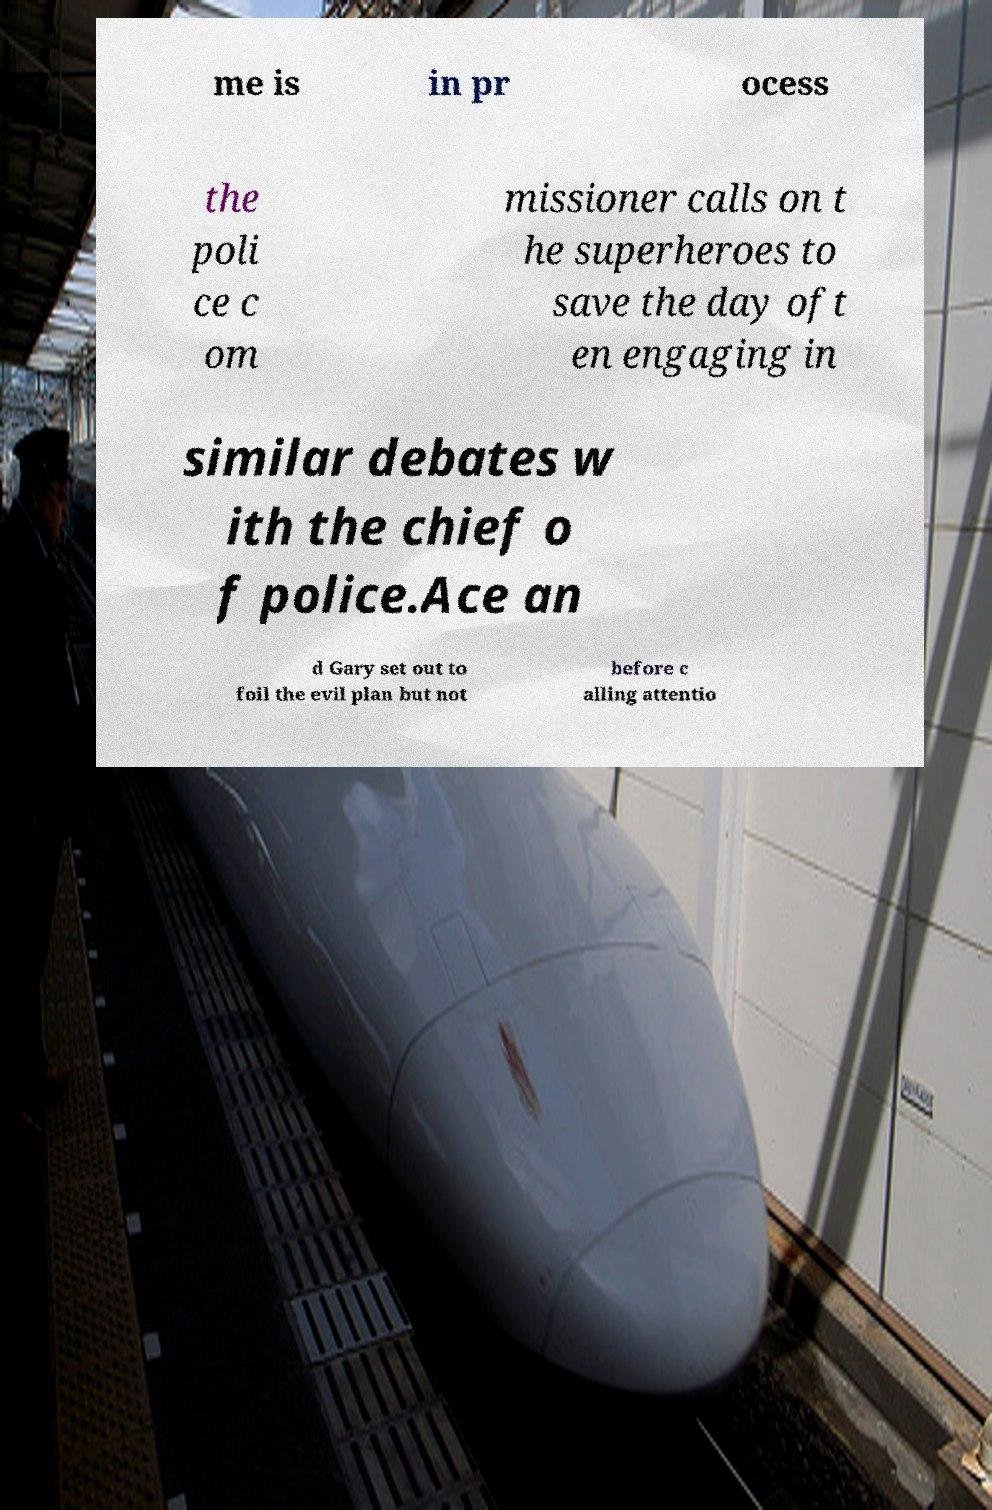Please read and relay the text visible in this image. What does it say? me is in pr ocess the poli ce c om missioner calls on t he superheroes to save the day oft en engaging in similar debates w ith the chief o f police.Ace an d Gary set out to foil the evil plan but not before c alling attentio 